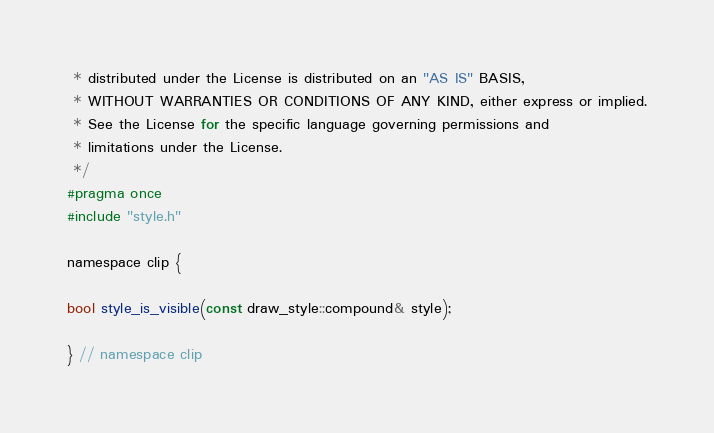<code> <loc_0><loc_0><loc_500><loc_500><_C_> * distributed under the License is distributed on an "AS IS" BASIS,
 * WITHOUT WARRANTIES OR CONDITIONS OF ANY KIND, either express or implied.
 * See the License for the specific language governing permissions and
 * limitations under the License.
 */
#pragma once
#include "style.h"

namespace clip {

bool style_is_visible(const draw_style::compound& style);

} // namespace clip

</code> 